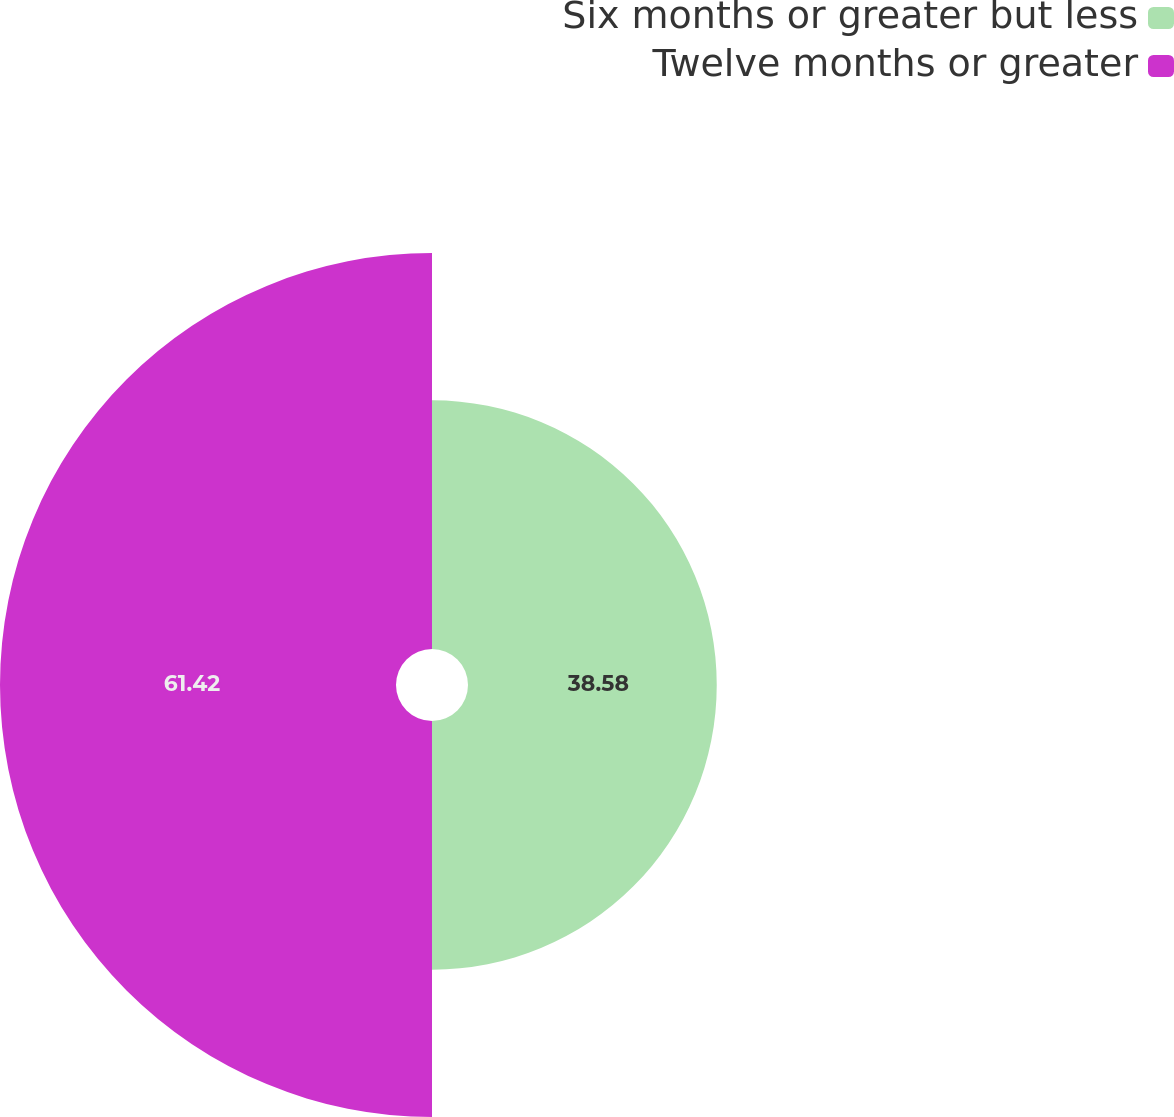Convert chart. <chart><loc_0><loc_0><loc_500><loc_500><pie_chart><fcel>Six months or greater but less<fcel>Twelve months or greater<nl><fcel>38.58%<fcel>61.42%<nl></chart> 